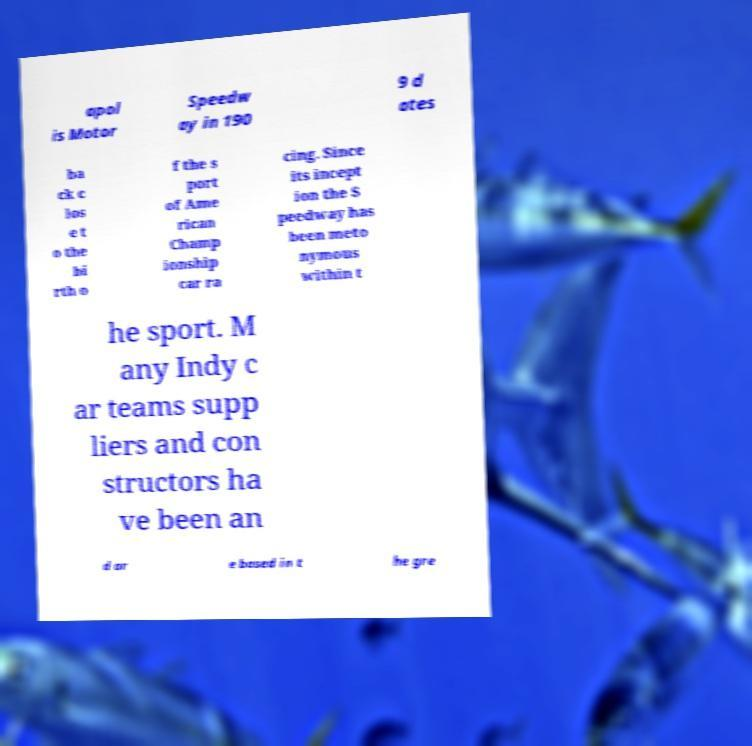I need the written content from this picture converted into text. Can you do that? apol is Motor Speedw ay in 190 9 d ates ba ck c los e t o the bi rth o f the s port of Ame rican Champ ionship car ra cing. Since its incept ion the S peedway has been meto nymous within t he sport. M any Indy c ar teams supp liers and con structors ha ve been an d ar e based in t he gre 